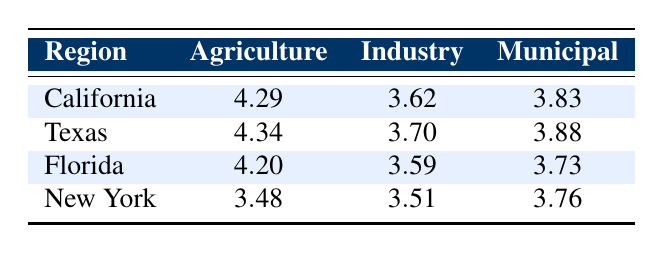What is the water usage for Agriculture in California? The table shows that the water usage for Agriculture in California is 4.29 (in logarithmic values).
Answer: 4.29 Which sector in Texas has the highest water usage? By comparing the water usage values for Texas across all sectors, Agriculture has the highest value of 4.34.
Answer: Agriculture Is New York's Municipal water usage greater than its Industry water usage? The table shows the values for New York as 3.76 for Municipal and 3.51 for Industry; since 3.76 is greater than 3.51, the conclusion is true.
Answer: Yes What is the total water usage (in logarithmic values) for Agriculture across all regions? Adding the values for Agriculture: 4.29 (California) + 4.34 (Texas) + 4.20 (Florida) + 3.48 (New York) = 16.31
Answer: 16.31 Is the Industry water usage in Florida less than the Municipal water usage in California? The values show that Florida's Industry water usage is 3.59 and California's Municipal is 3.83. Since 3.59 is less than 3.83, the answer is true.
Answer: Yes What is the average water usage for the Municipal sector across all regions? The Municipal values are 3.83 (California), 3.88 (Texas), 3.73 (Florida), and 3.76 (New York). The sum is 3.83 + 3.88 + 3.73 + 3.76 = 15.20. Dividing by 4 gives an average of 3.80.
Answer: 3.80 Which region has the lowest water usage for the Agriculture sector? Comparing the Agriculture values: California (4.29), Texas (4.34), Florida (4.20), and New York (3.48), New York has the lowest at 3.48.
Answer: New York If Florida's Industry and California's Municipal water usages are combined, what is the result? The values are Florida's Industry (3.59) and California's Municipal (3.83). Adding these gives 3.59 + 3.83 = 7.42.
Answer: 7.42 Is Texas's total water usage for all sectors greater than California's total water usage? The total for California is 4.29 + 3.62 + 3.83 = 11.74. For Texas, it's 4.34 + 3.70 + 3.88 = 11.92. Since 11.92 is greater than 11.74, it confirms that Texas's total is indeed greater.
Answer: Yes 